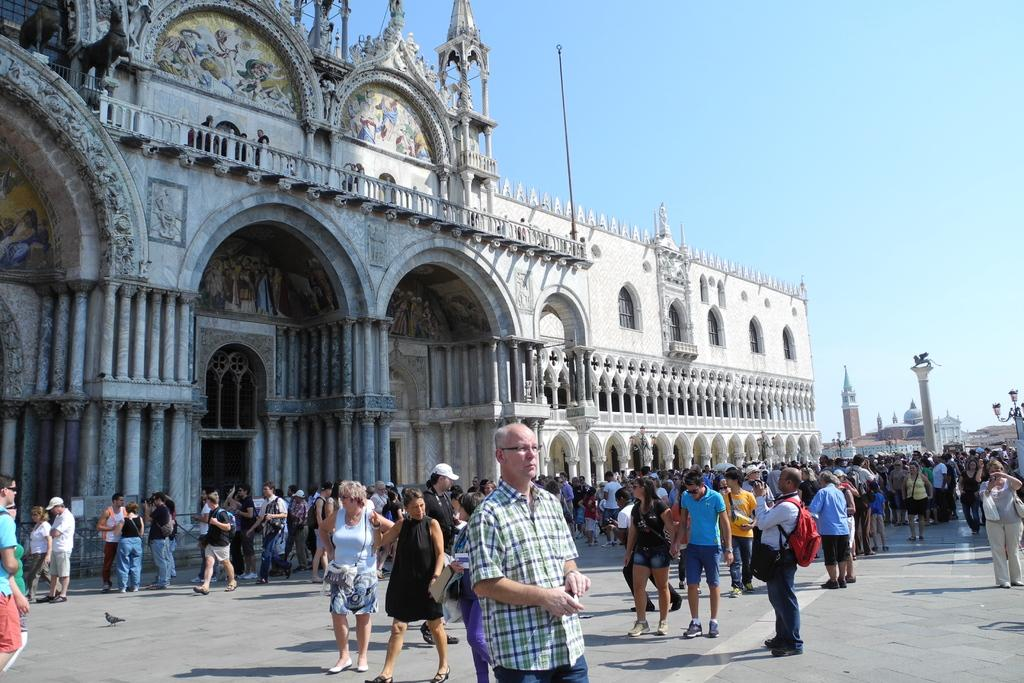What type of structure is present in the image? There is a building in the image. What architectural features can be seen on the building? The building has pillars and windows. What else is visible in the image besides the building? There are people standing on the road and a pole in the image. What can be seen in the background of the image? The sky is visible in the image. How many grapes are hanging from the pole in the image? There are no grapes present in the image; the pole is not associated with any grapes. 